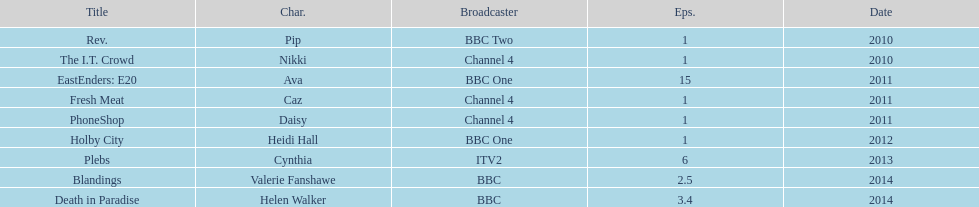How many episodes did sophie colquhoun star in on rev.? 1. What character did she play on phoneshop? Daisy. What role did she play on itv2? Cynthia. 